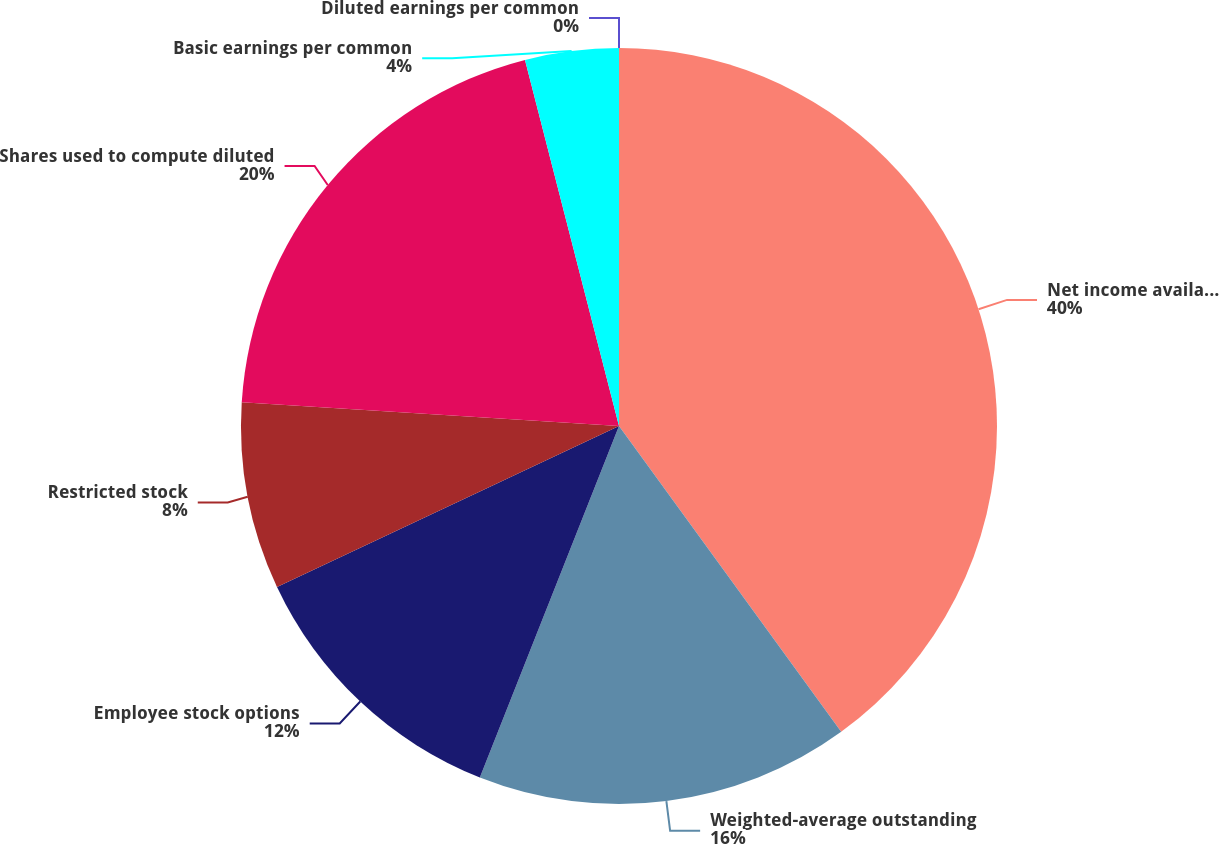<chart> <loc_0><loc_0><loc_500><loc_500><pie_chart><fcel>Net income available for<fcel>Weighted-average outstanding<fcel>Employee stock options<fcel>Restricted stock<fcel>Shares used to compute diluted<fcel>Basic earnings per common<fcel>Diluted earnings per common<nl><fcel>40.0%<fcel>16.0%<fcel>12.0%<fcel>8.0%<fcel>20.0%<fcel>4.0%<fcel>0.0%<nl></chart> 